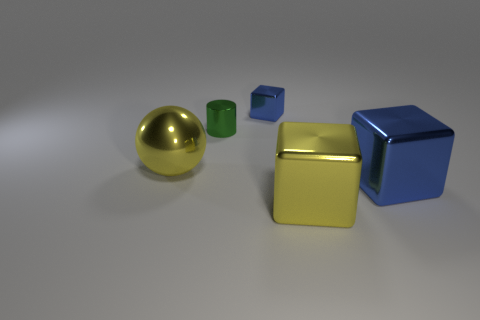What materials do the objects in the image appear to be made of? The objects in the image appear to have different materials. The ball seems to be made of a shiny metal, possibly gold in color. The green object looks like matte plastic, and both the blue and the golden yellow objects appear to have shiny, reflective surfaces that could be metallic or plastic with a metallic finish. 